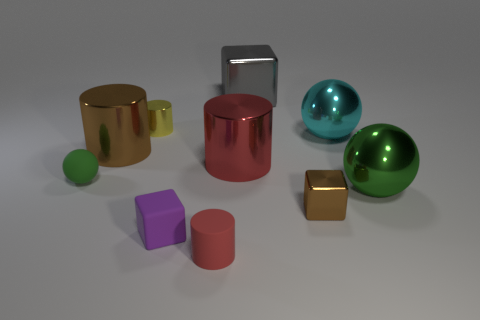What shape is the shiny thing that is the same color as the small matte cylinder?
Your response must be concise. Cylinder. There is a yellow cylinder that is made of the same material as the big green sphere; what size is it?
Offer a very short reply. Small. What shape is the green object that is to the left of the large metal ball that is in front of the large metal object left of the yellow metal object?
Make the answer very short. Sphere. Is the number of brown cubes to the left of the small green matte ball the same as the number of tiny blue metallic objects?
Make the answer very short. Yes. There is a metallic object that is the same color as the matte sphere; what is its size?
Give a very brief answer. Large. Does the yellow metallic thing have the same shape as the large brown metal object?
Your answer should be very brief. Yes. How many objects are either cylinders that are in front of the large brown shiny cylinder or yellow cylinders?
Provide a succinct answer. 3. Are there the same number of brown objects to the right of the small red thing and tiny matte cylinders that are to the left of the tiny purple cube?
Provide a succinct answer. No. What number of other objects are the same shape as the purple matte object?
Your response must be concise. 2. Is the size of the metallic sphere to the left of the big green sphere the same as the cube that is to the left of the small red object?
Your response must be concise. No. 